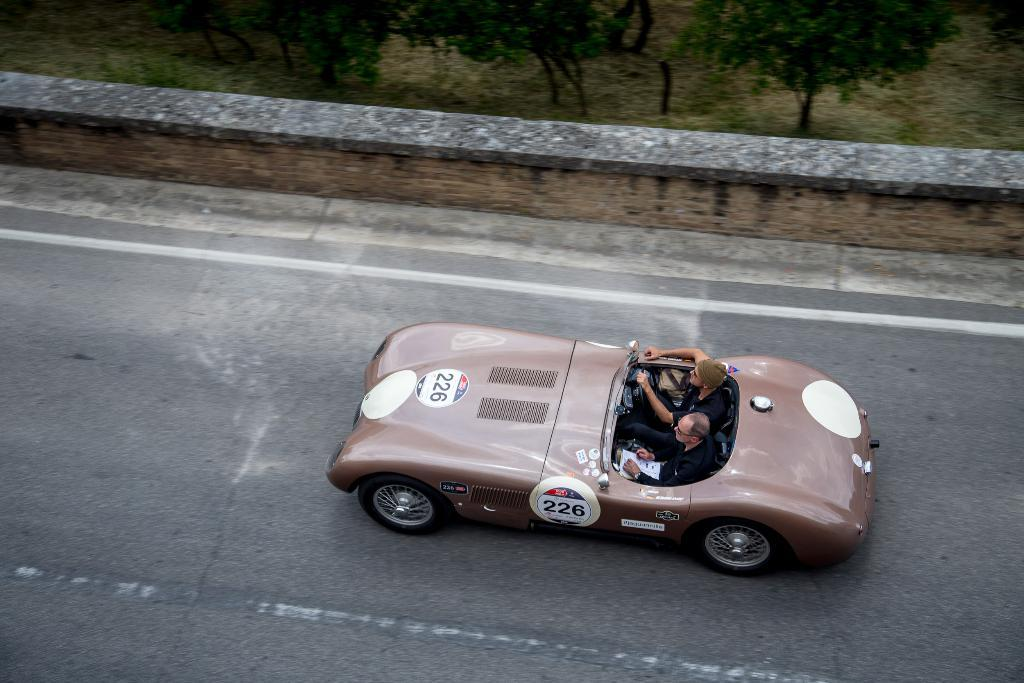What is the main subject of the image? The main subject of the image is a car on the road. Can you describe the car's appearance? The car is light brown in color. Who is inside the car? There are two men in the car. What are the men wearing? The men are wearing black clothes. What can be seen in the background of the image? There are trees visible at the top of the image. What songs are the men singing in the car? There is no information about the men singing songs in the image. How many letters are visible on the car's license plate? The image does not provide a clear view of the car's license plate, so it is impossible to determine the number of letters. 